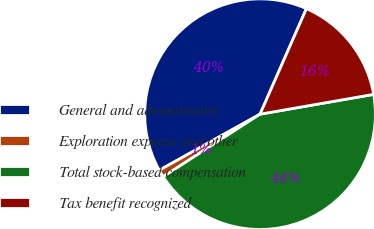Convert chart. <chart><loc_0><loc_0><loc_500><loc_500><pie_chart><fcel>General and administrative<fcel>Exploration expense and other<fcel>Total stock-based compensation<fcel>Tax benefit recognized<nl><fcel>39.67%<fcel>1.04%<fcel>43.63%<fcel>15.66%<nl></chart> 